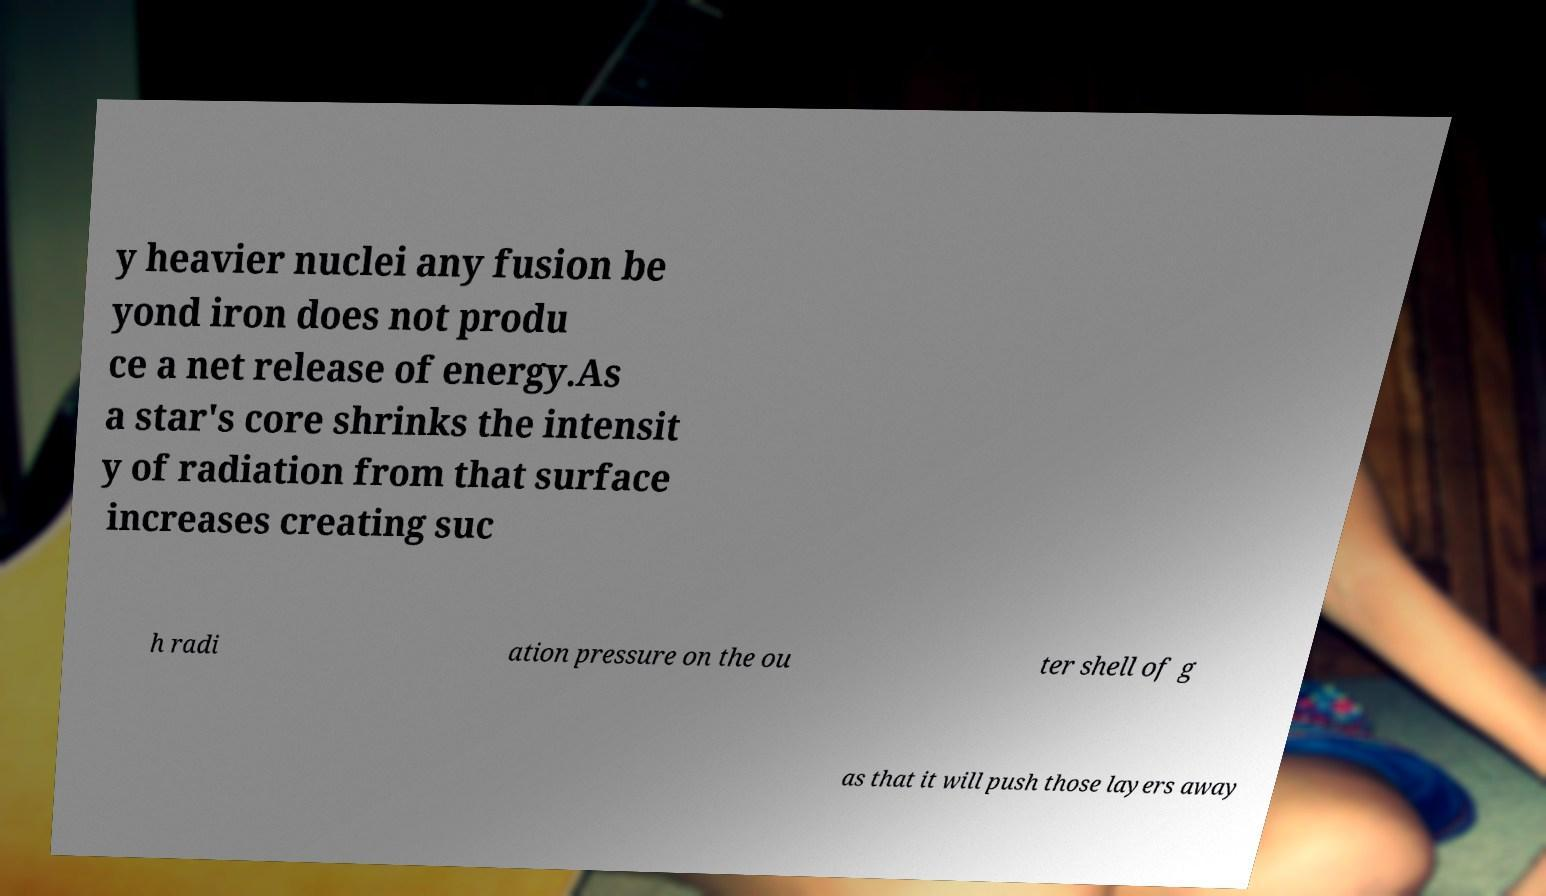Can you read and provide the text displayed in the image?This photo seems to have some interesting text. Can you extract and type it out for me? y heavier nuclei any fusion be yond iron does not produ ce a net release of energy.As a star's core shrinks the intensit y of radiation from that surface increases creating suc h radi ation pressure on the ou ter shell of g as that it will push those layers away 